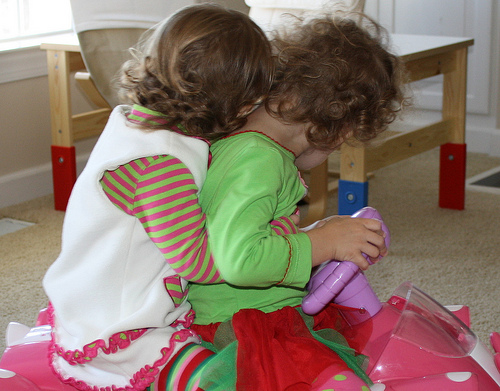<image>
Can you confirm if the toy is on the baby? No. The toy is not positioned on the baby. They may be near each other, but the toy is not supported by or resting on top of the baby. 